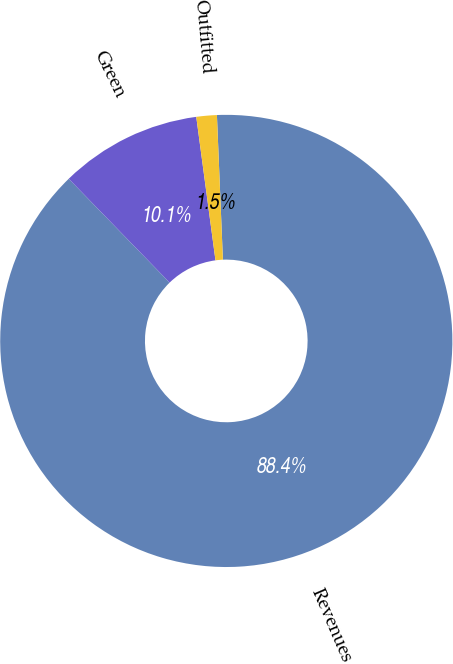Convert chart. <chart><loc_0><loc_0><loc_500><loc_500><pie_chart><fcel>Revenues<fcel>Green<fcel>Outfitted<nl><fcel>88.39%<fcel>10.15%<fcel>1.46%<nl></chart> 